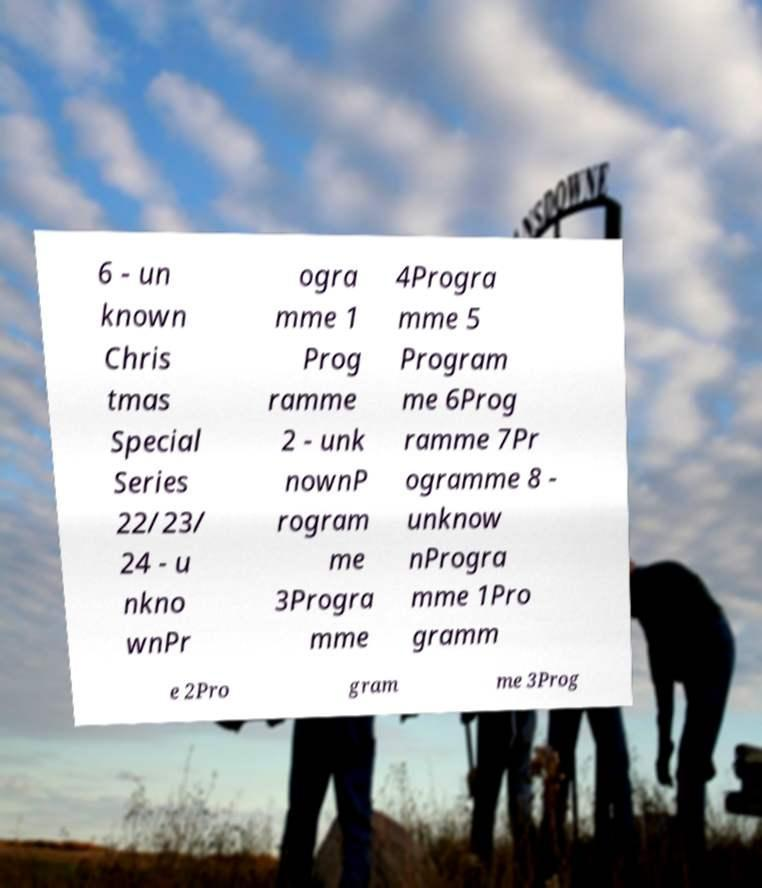Could you extract and type out the text from this image? 6 - un known Chris tmas Special Series 22/23/ 24 - u nkno wnPr ogra mme 1 Prog ramme 2 - unk nownP rogram me 3Progra mme 4Progra mme 5 Program me 6Prog ramme 7Pr ogramme 8 - unknow nProgra mme 1Pro gramm e 2Pro gram me 3Prog 